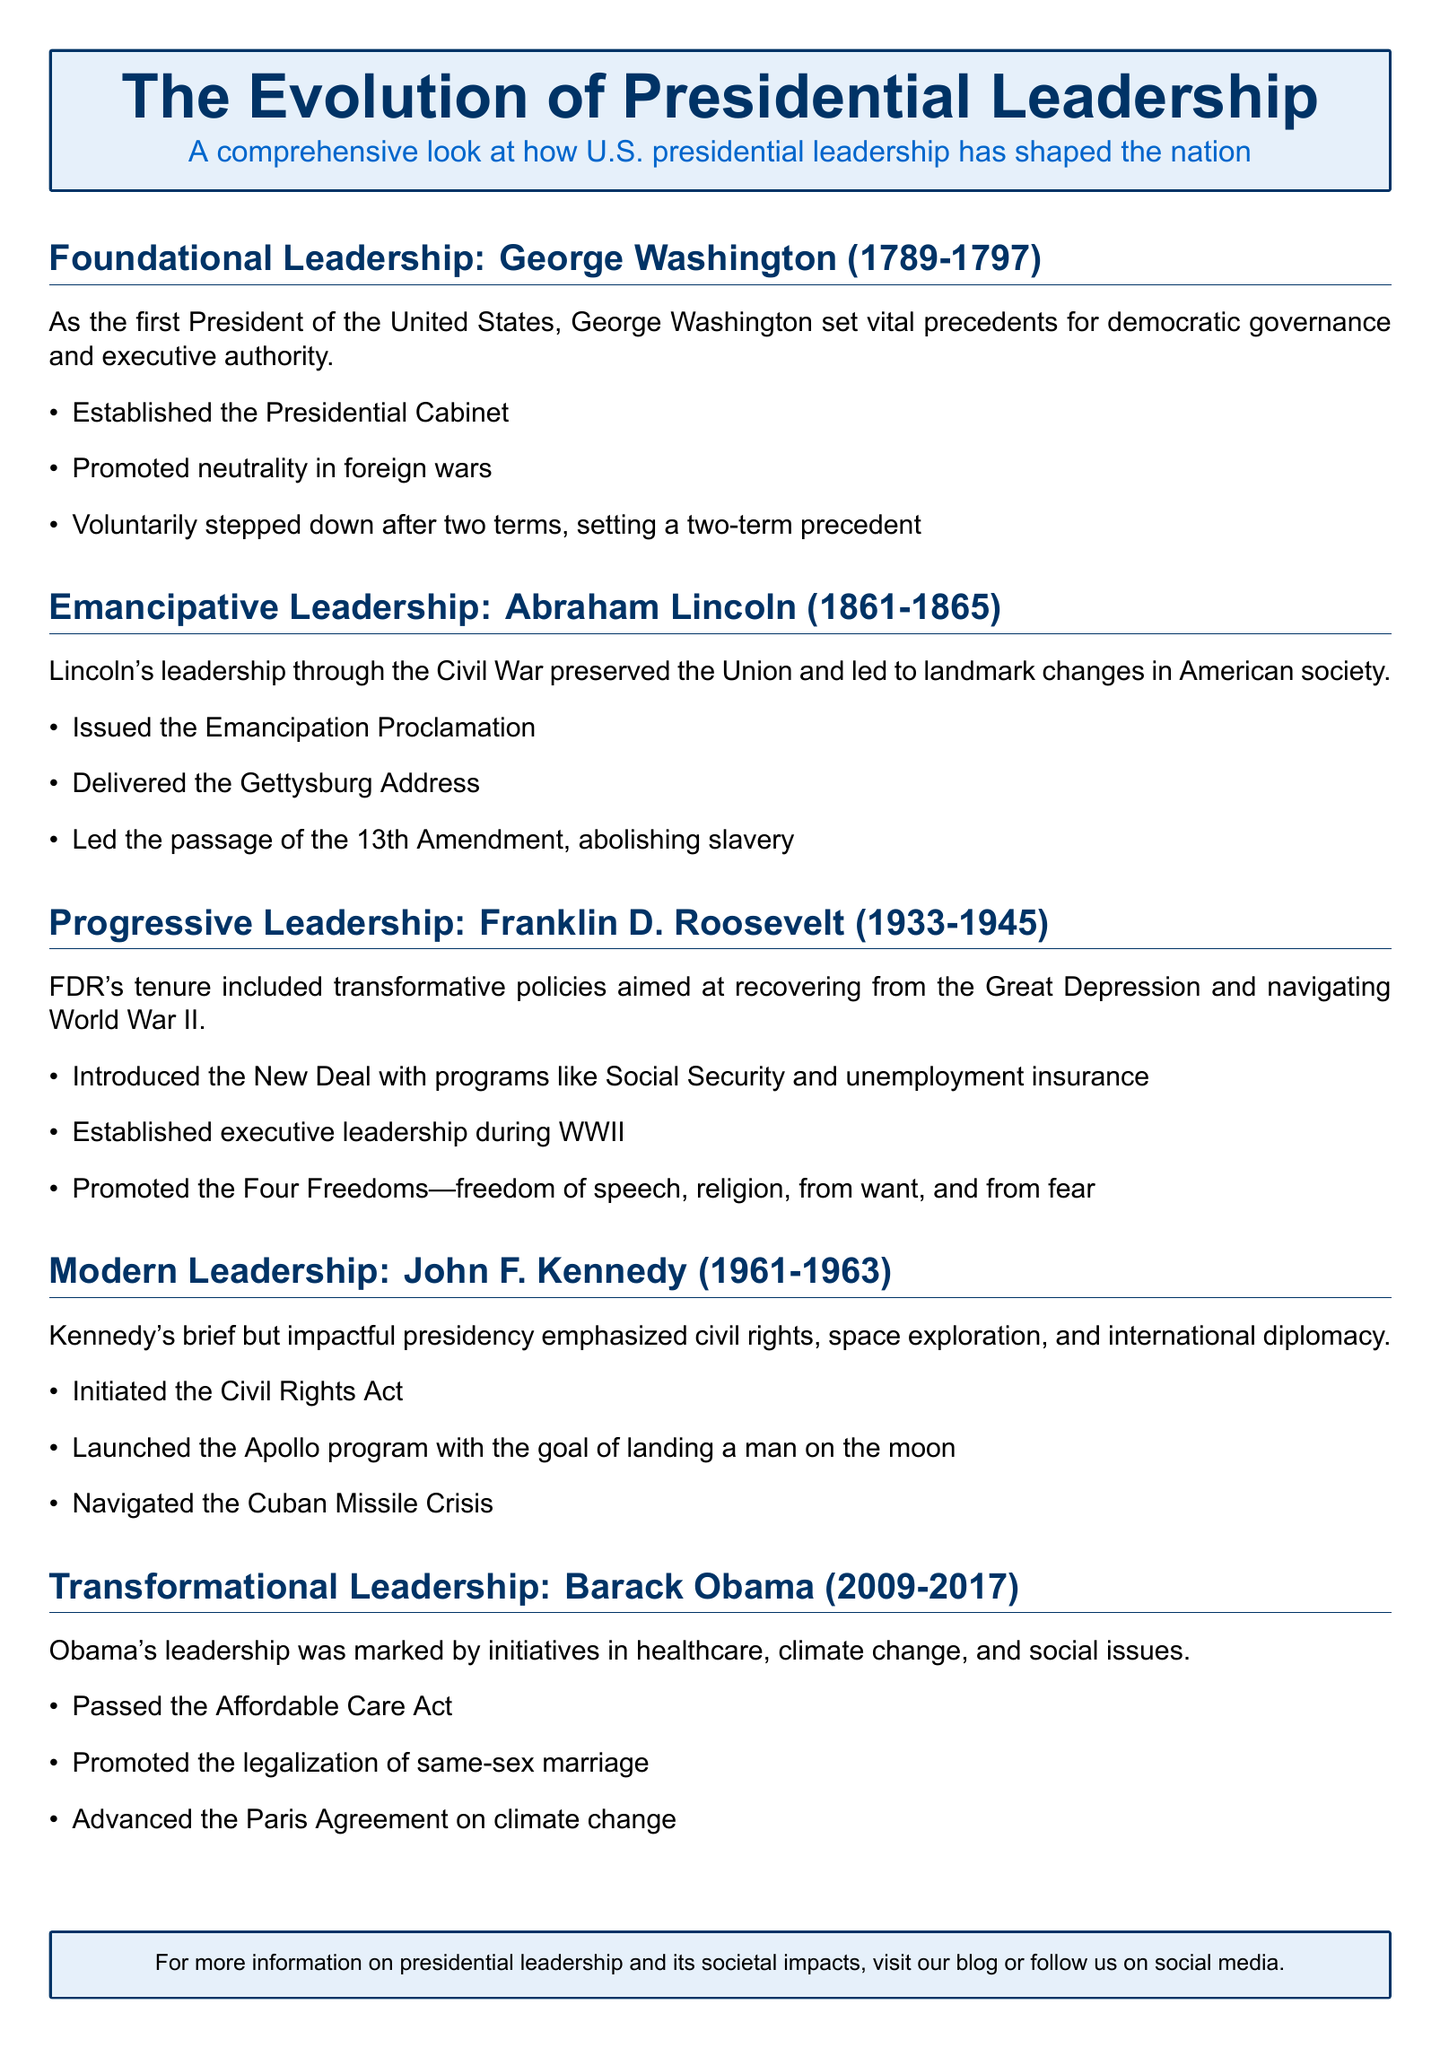What was the term length of George Washington? The document states that George Washington served from 1789 to 1797. The term length is 8 years.
Answer: 8 years What landmark legislation did Abraham Lincoln pass? Lincoln led the passage of the 13th Amendment, which abolished slavery.
Answer: 13th Amendment Which program did Franklin D. Roosevelt introduce for unemployment insurance? The New Deal included programs like Social Security and unemployment insurance.
Answer: New Deal What initiative did John F. Kennedy launch related to space exploration? Kennedy initiated the Apollo program with the goal of landing a man on the moon.
Answer: Apollo program What major healthcare legislation was passed during Barack Obama's presidency? The document mentions the passage of the Affordable Care Act during Obama's leadership.
Answer: Affordable Care Act Which president established the Presidential Cabinet? The foundational leadership section states that George Washington established the Presidential Cabinet.
Answer: George Washington What was a key focus of Franklin D. Roosevelt's leadership during World War II? FDR established executive leadership during WWII as a key focus of his leadership.
Answer: Executive leadership during WWII How did Lincoln's presidency impact society during the Civil War? Lincoln's leadership is noted for preserving the Union and leading to landmark changes such as the Emancipation Proclamation.
Answer: Preserved the Union Which concept did Franklin D. Roosevelt promote that included four freedoms? FDR promoted the Four Freedoms, which included freedom of speech, religion, from want, and from fear.
Answer: Four Freedoms 